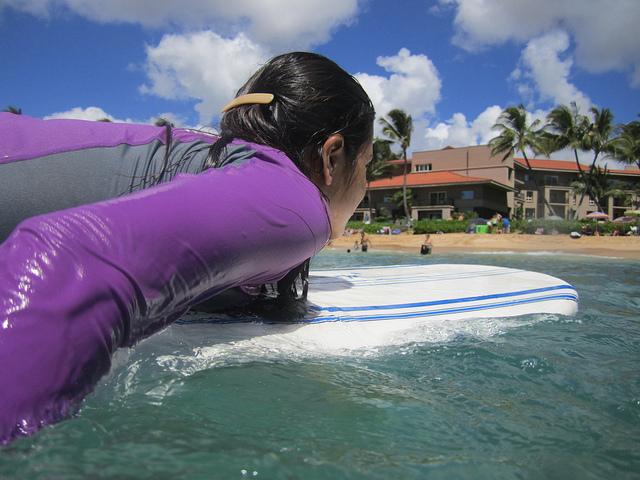What is she laying on?
Quick response, please. Surfboard. Is this a woman?
Be succinct. Yes. How deep is the water?
Quick response, please. 5 feet. What color is her wetsuit?
Concise answer only. Purple. 